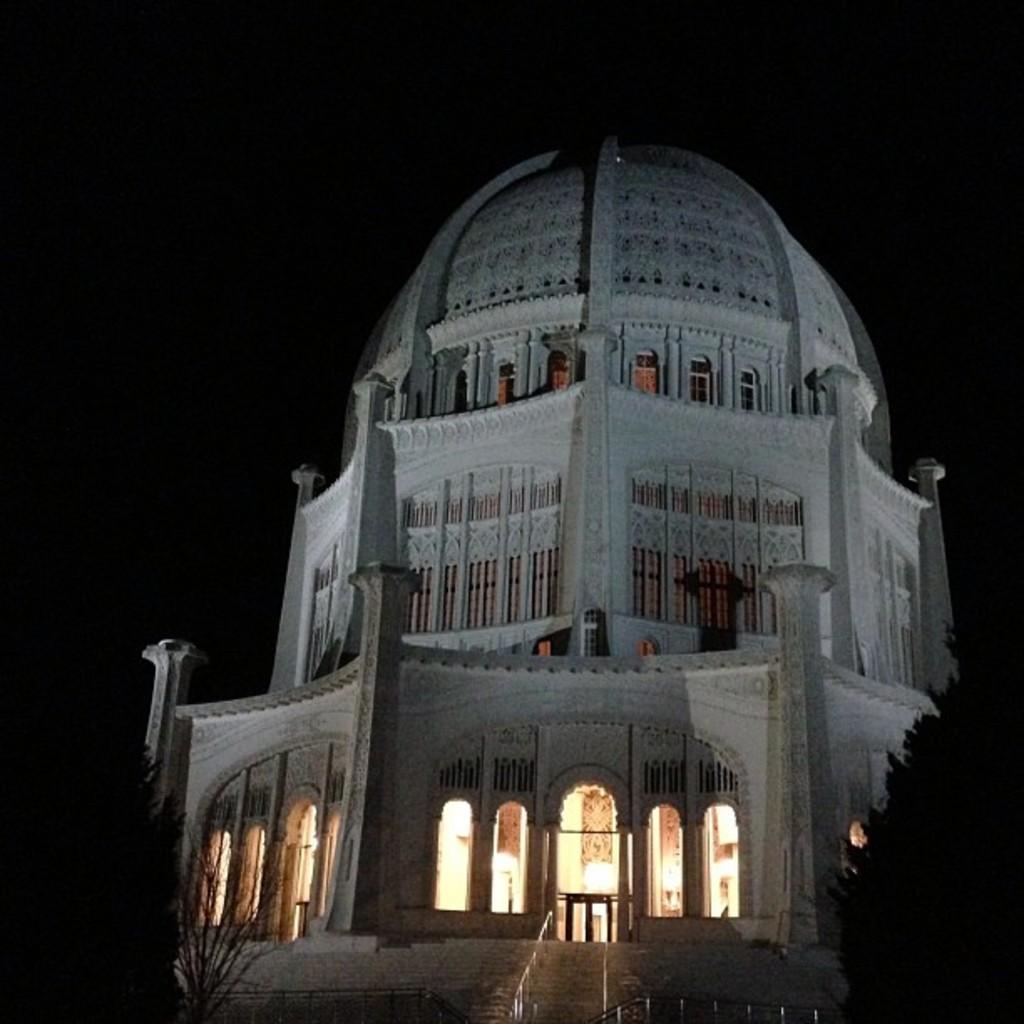Can you describe this image briefly? This picture is clicked outside. In the center we can see a building and the dome is attached to the building. In the foreground we can see the stairs and the trees. In the background there is a sky. 